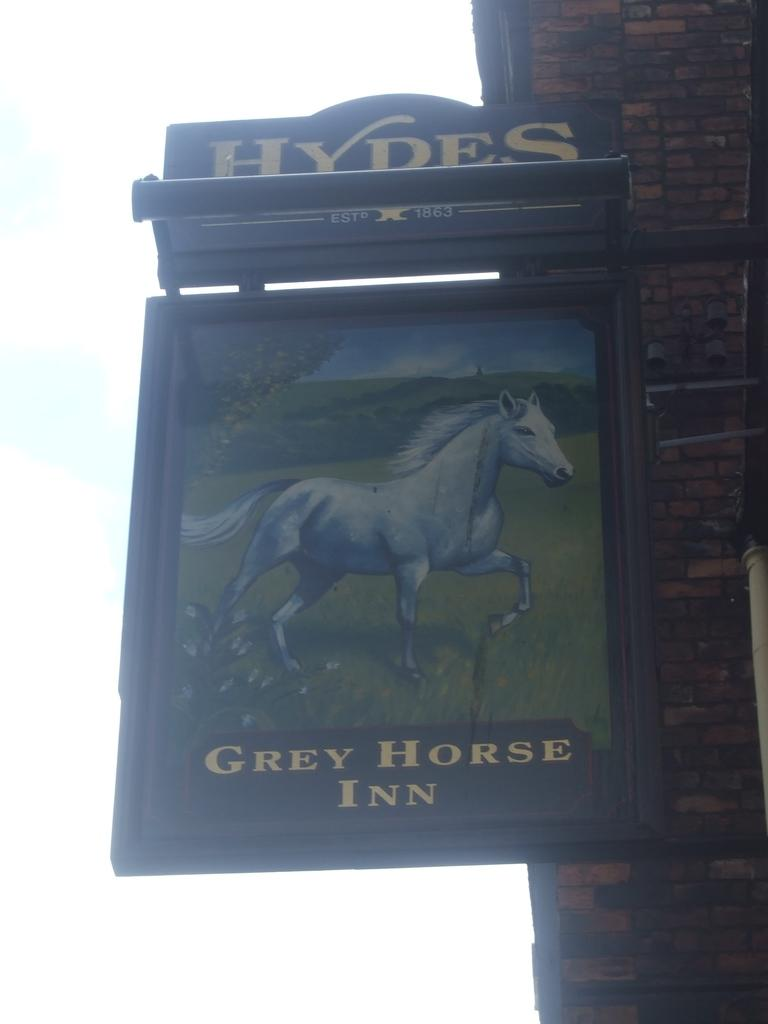What is attached to the wall in the image? There is a board attached to the wall in the image. What is depicted on the board? There is a horse depicted on the board. What can be seen in the background of the image? The sky is visible in the background of the image. What is the color of the sky in the image? The sky is described as white in color. How many cakes are displayed on the board in the image? There are no cakes present in the image; the board features a depiction of a horse. 